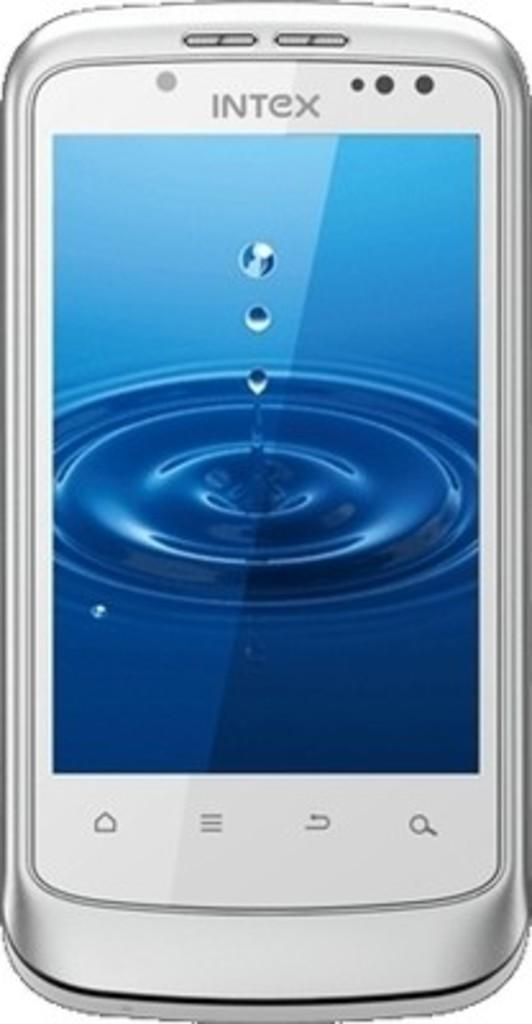What electronic device is in the picture? There is a smartphone in the picture. What features does the smartphone have? The smartphone has buttons, a screen, a speaker, a camera, and sensors. How is the smartphone positioned in the image? The smartphone is placed on a white backdrop. What type of disgust can be seen on the committee's faces in the image? There is no committee or any faces present in the image; it features a smartphone on a white backdrop. 